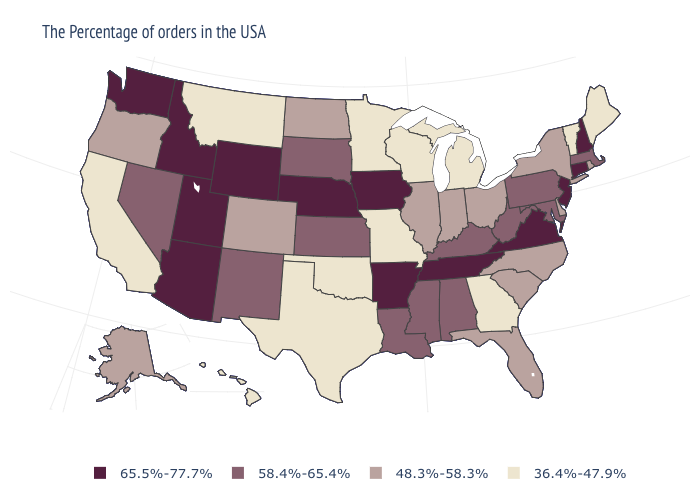Name the states that have a value in the range 48.3%-58.3%?
Be succinct. Rhode Island, New York, Delaware, North Carolina, South Carolina, Ohio, Florida, Indiana, Illinois, North Dakota, Colorado, Oregon, Alaska. What is the value of New Mexico?
Keep it brief. 58.4%-65.4%. Name the states that have a value in the range 58.4%-65.4%?
Give a very brief answer. Massachusetts, Maryland, Pennsylvania, West Virginia, Kentucky, Alabama, Mississippi, Louisiana, Kansas, South Dakota, New Mexico, Nevada. Name the states that have a value in the range 36.4%-47.9%?
Give a very brief answer. Maine, Vermont, Georgia, Michigan, Wisconsin, Missouri, Minnesota, Oklahoma, Texas, Montana, California, Hawaii. What is the value of Georgia?
Concise answer only. 36.4%-47.9%. Does Alabama have the highest value in the South?
Keep it brief. No. Does the map have missing data?
Short answer required. No. How many symbols are there in the legend?
Quick response, please. 4. Which states have the highest value in the USA?
Concise answer only. New Hampshire, Connecticut, New Jersey, Virginia, Tennessee, Arkansas, Iowa, Nebraska, Wyoming, Utah, Arizona, Idaho, Washington. Which states have the highest value in the USA?
Short answer required. New Hampshire, Connecticut, New Jersey, Virginia, Tennessee, Arkansas, Iowa, Nebraska, Wyoming, Utah, Arizona, Idaho, Washington. Does Missouri have the highest value in the MidWest?
Be succinct. No. Name the states that have a value in the range 58.4%-65.4%?
Give a very brief answer. Massachusetts, Maryland, Pennsylvania, West Virginia, Kentucky, Alabama, Mississippi, Louisiana, Kansas, South Dakota, New Mexico, Nevada. Name the states that have a value in the range 48.3%-58.3%?
Concise answer only. Rhode Island, New York, Delaware, North Carolina, South Carolina, Ohio, Florida, Indiana, Illinois, North Dakota, Colorado, Oregon, Alaska. What is the value of Pennsylvania?
Keep it brief. 58.4%-65.4%. Which states hav the highest value in the West?
Be succinct. Wyoming, Utah, Arizona, Idaho, Washington. 